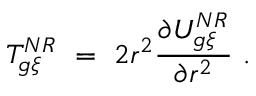Convert formula to latex. <formula><loc_0><loc_0><loc_500><loc_500>T _ { g \xi } ^ { N R } \ = \ 2 r ^ { 2 } \frac { \partial U _ { g \xi } ^ { N R } } { \partial r ^ { 2 } } \ .</formula> 